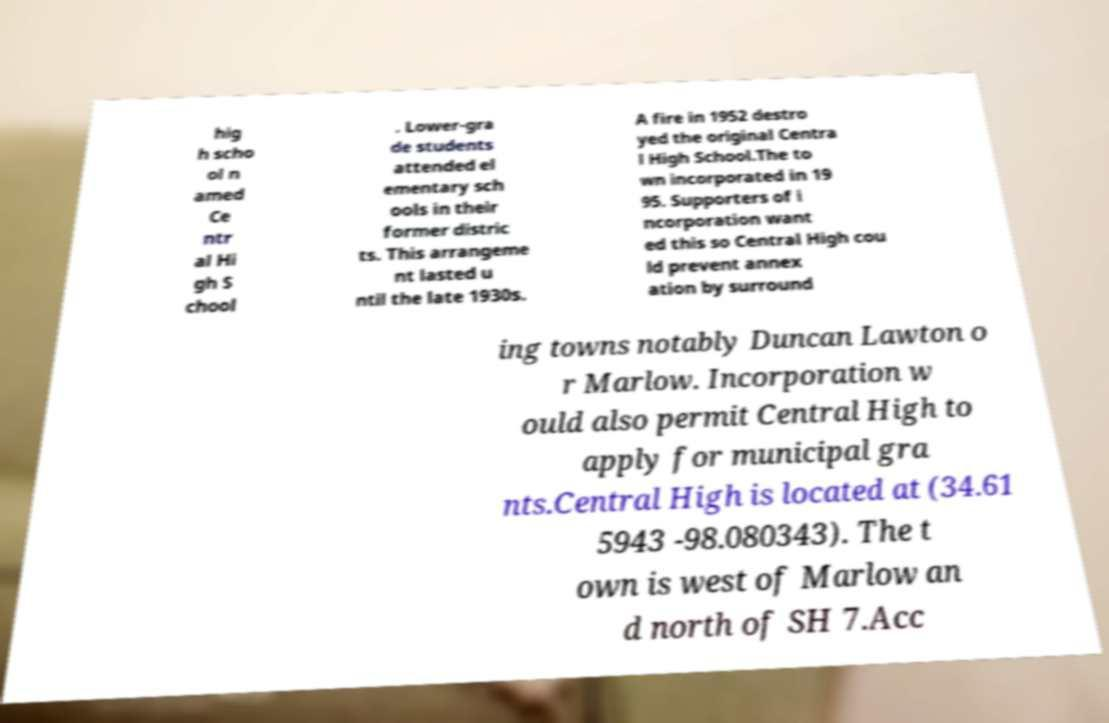What messages or text are displayed in this image? I need them in a readable, typed format. hig h scho ol n amed Ce ntr al Hi gh S chool . Lower-gra de students attended el ementary sch ools in their former distric ts. This arrangeme nt lasted u ntil the late 1930s. A fire in 1952 destro yed the original Centra l High School.The to wn incorporated in 19 95. Supporters of i ncorporation want ed this so Central High cou ld prevent annex ation by surround ing towns notably Duncan Lawton o r Marlow. Incorporation w ould also permit Central High to apply for municipal gra nts.Central High is located at (34.61 5943 -98.080343). The t own is west of Marlow an d north of SH 7.Acc 